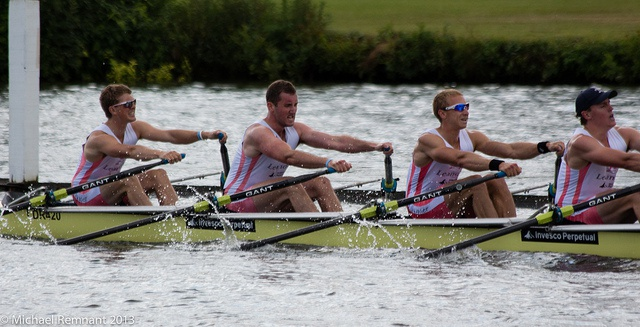Describe the objects in this image and their specific colors. I can see boat in black, olive, gray, and darkgray tones, people in black, brown, and maroon tones, people in black, maroon, and brown tones, people in black, gray, and maroon tones, and people in black, maroon, gray, and brown tones in this image. 